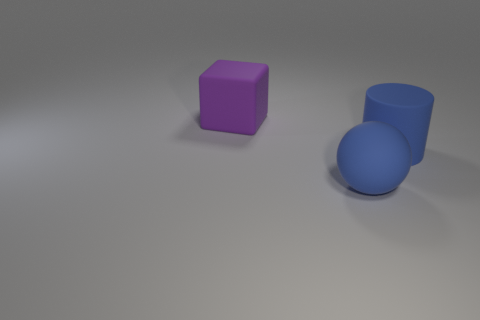Add 1 large matte cylinders. How many objects exist? 4 Subtract all blocks. How many objects are left? 2 Subtract all big rubber cylinders. Subtract all big purple things. How many objects are left? 1 Add 3 large purple rubber blocks. How many large purple rubber blocks are left? 4 Add 3 big purple cubes. How many big purple cubes exist? 4 Subtract 1 blue spheres. How many objects are left? 2 